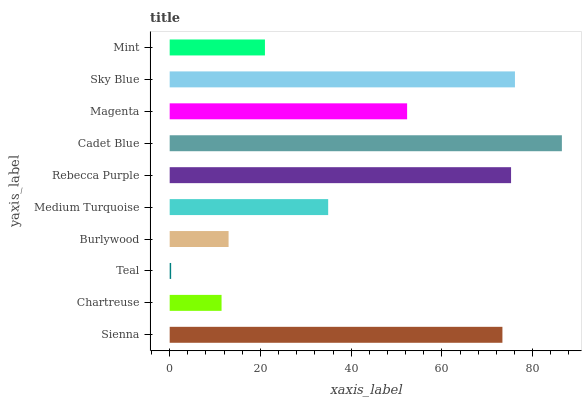Is Teal the minimum?
Answer yes or no. Yes. Is Cadet Blue the maximum?
Answer yes or no. Yes. Is Chartreuse the minimum?
Answer yes or no. No. Is Chartreuse the maximum?
Answer yes or no. No. Is Sienna greater than Chartreuse?
Answer yes or no. Yes. Is Chartreuse less than Sienna?
Answer yes or no. Yes. Is Chartreuse greater than Sienna?
Answer yes or no. No. Is Sienna less than Chartreuse?
Answer yes or no. No. Is Magenta the high median?
Answer yes or no. Yes. Is Medium Turquoise the low median?
Answer yes or no. Yes. Is Medium Turquoise the high median?
Answer yes or no. No. Is Teal the low median?
Answer yes or no. No. 